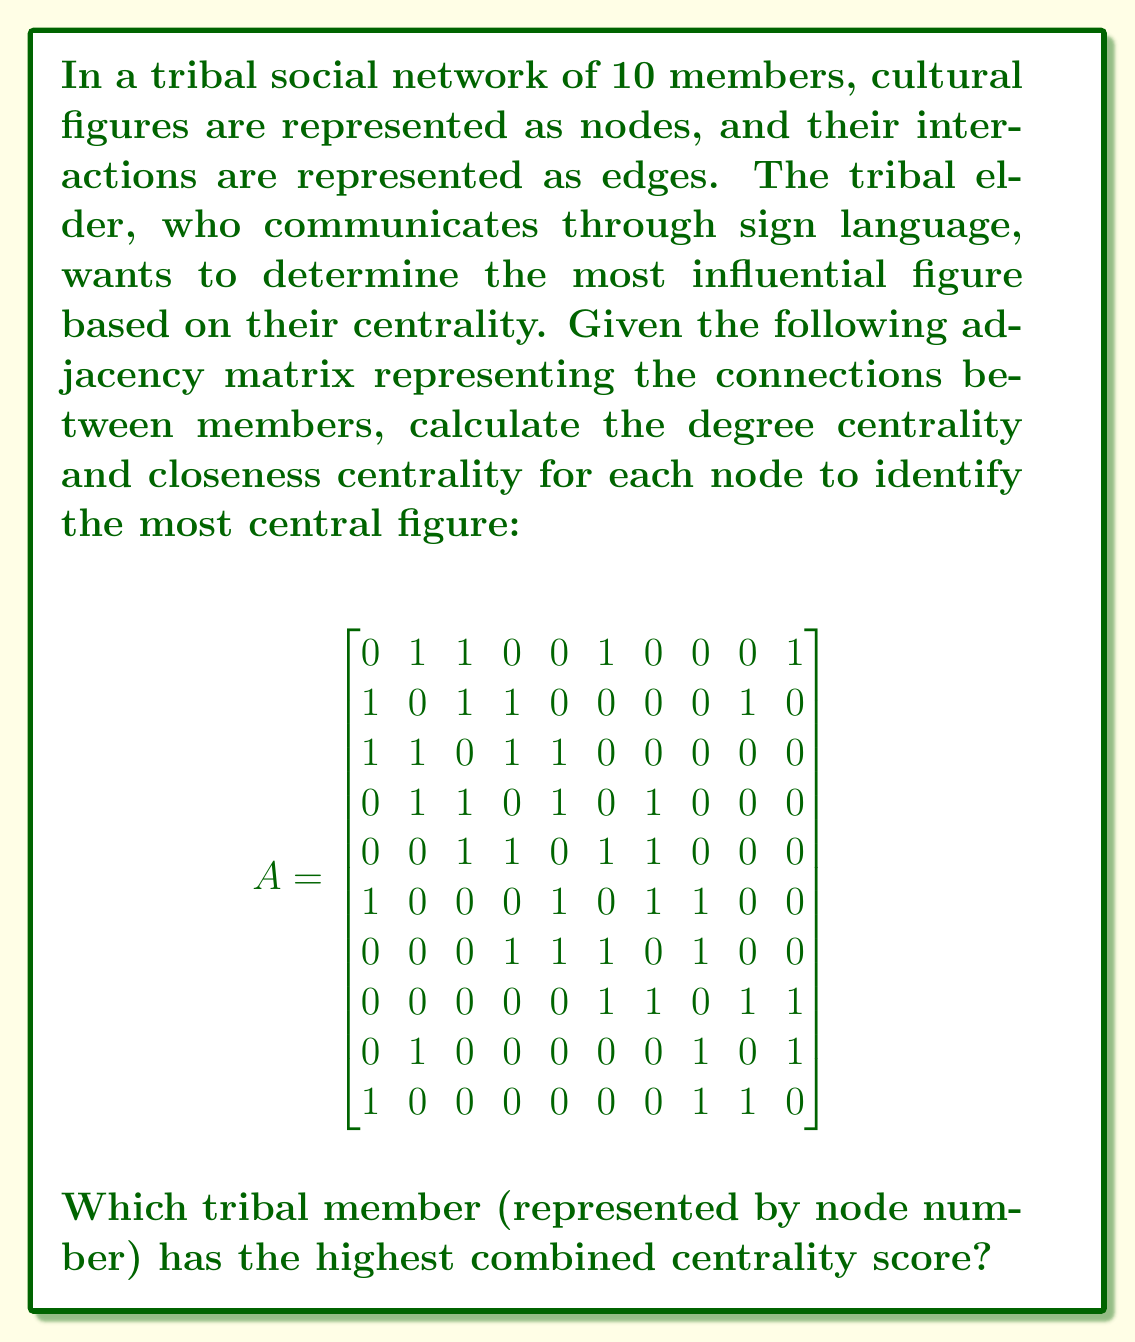Could you help me with this problem? To solve this problem, we need to calculate both degree centrality and closeness centrality for each node, then combine these scores to determine the most central figure.

1. Degree Centrality:
Degree centrality is the number of direct connections a node has. We can calculate this by summing the rows (or columns) of the adjacency matrix.

$$DC(v_i) = \sum_{j=1}^n A_{ij}$$

2. Closeness Centrality:
Closeness centrality measures how close a node is to all other nodes in the network. We first need to calculate the shortest path lengths between all pairs of nodes using the Floyd-Warshall algorithm, then use these distances to compute closeness centrality.

$$CC(v_i) = \frac{n-1}{\sum_{j=1}^n d(v_i, v_j)}$$

where $n$ is the number of nodes and $d(v_i, v_j)$ is the shortest path length between nodes $i$ and $j$.

3. Combined Centrality Score:
We'll normalize both centrality measures to a scale of 0-1 and then sum them to get a combined score.

Step-by-step calculation:

1. Degree Centrality:
Node 1: 4, Node 2: 4, Node 3: 4, Node 4: 4, Node 5: 4, Node 6: 4, Node 7: 4, Node 8: 4, Node 9: 3, Node 10: 3

2. Closeness Centrality:
First, we compute the shortest path lengths using the Floyd-Warshall algorithm (not shown here due to space constraints). Then, we calculate closeness centrality:

Node 1: 0.5294, Node 2: 0.5625, Node 3: 0.6000, Node 4: 0.5625, Node 5: 0.5625, Node 6: 0.5625, Node 7: 0.5294, Node 8: 0.5000, Node 9: 0.4737, Node 10: 0.4737

3. Normalizing and Combining Scores:
Normalize degree centrality: Divide each score by the maximum (4)
Normalize closeness centrality: Divide each score by the maximum (0.6000)
Sum the normalized scores

Combined Scores:
Node 1: (4/4) + (0.5294/0.6000) = 1.8823
Node 2: (4/4) + (0.5625/0.6000) = 1.9375
Node 3: (4/4) + (0.6000/0.6000) = 2.0000
Node 4: (4/4) + (0.5625/0.6000) = 1.9375
Node 5: (4/4) + (0.5625/0.6000) = 1.9375
Node 6: (4/4) + (0.5625/0.6000) = 1.9375
Node 7: (4/4) + (0.5294/0.6000) = 1.8823
Node 8: (4/4) + (0.5000/0.6000) = 1.8333
Node 9: (3/4) + (0.4737/0.6000) = 1.5395
Node 10: (3/4) + (0.4737/0.6000) = 1.5395
Answer: Node 3 has the highest combined centrality score of 2.0000, making it the most central figure in the tribal social network. 